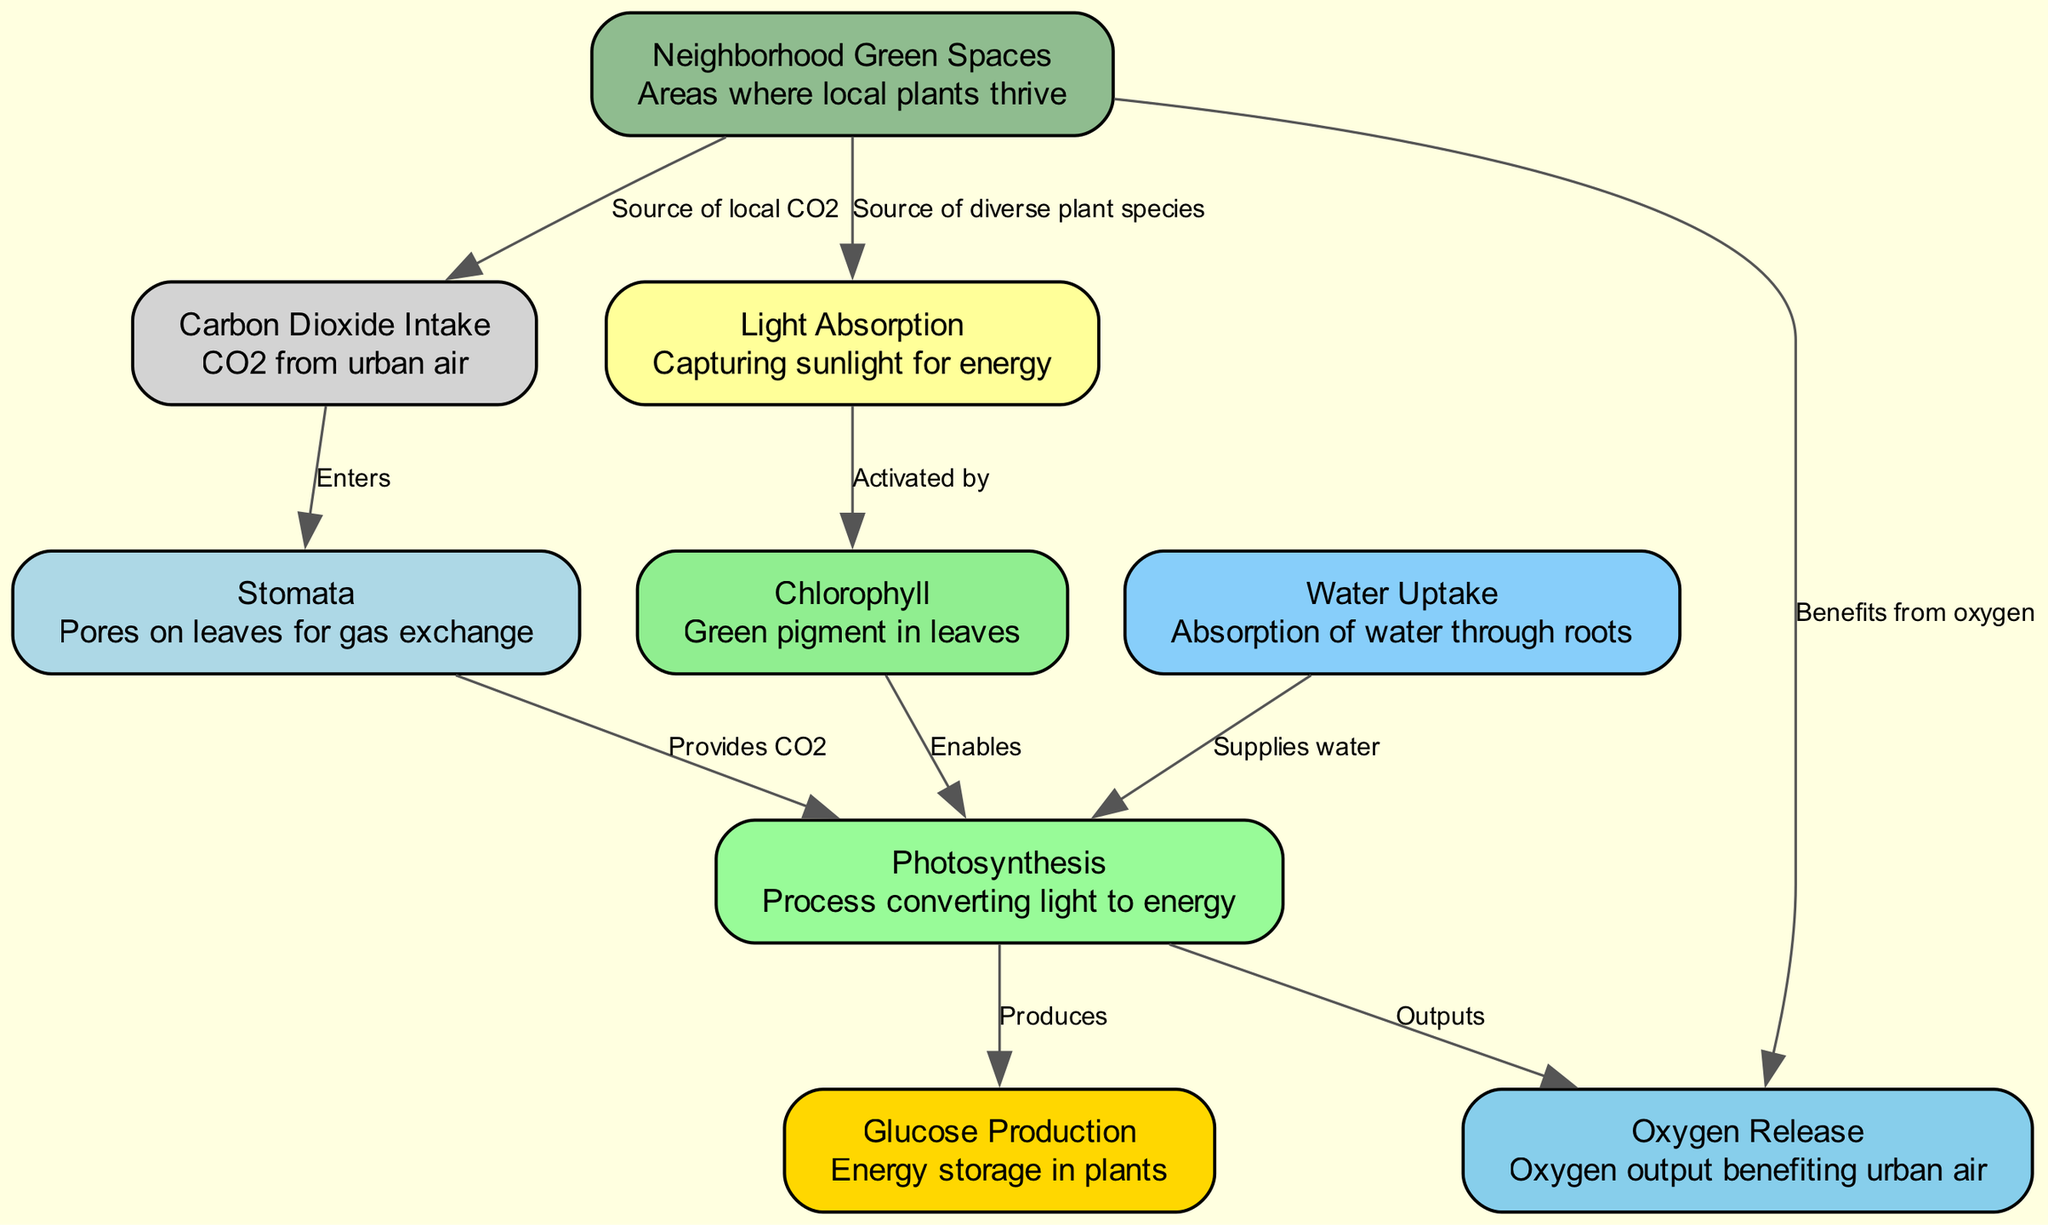What is the label of the node that corresponds to sunlight absorption? The node for sunlight absorption is labeled "Light Absorption". This can be determined by looking for the node in the diagram that explicitly mentions the process of capturing sunlight.
Answer: Light Absorption How many edges are shown in the diagram? To count the edges, we can note each connection between nodes. The edges listed show the relationships and there are a total of 9 edges in the diagram.
Answer: 9 Which node represents the process that converts light to energy? The process that converts light to energy is represented by the node labeled "Photosynthesis". This can be found by locating the node that ties together the input of light and outputs the energy forms.
Answer: Photosynthesis What does the "Chlorophyll" node enable in the process? The "Chlorophyll" node enables the "Photosynthesis" process. This connection indicates that chlorophyll is crucial for converting light energy during photosynthesis.
Answer: Photosynthesis Which node receives Carbon Dioxide from urban air? The node that receives Carbon Dioxide from urban air is labeled "Stomata". This can be identified by observing the node that connects to CO2 intake and serves the gas exchange function.
Answer: Stomata Which area benefits from the oxygen released during photosynthesis? The area that benefits from the oxygen released is labeled "Neighborhood Green Spaces". This can be concluded by looking for the node that is indicated to receive the oxygen output from the photosynthesis chain.
Answer: Neighborhood Green Spaces What performs the function of absorbing water for the plant? The function of absorbing water for the plant is performed by the node labeled "Water Uptake". This node directly relates to the roots' capability to supply water for photosynthesis.
Answer: Water Uptake How does "Carbon Dioxide Intake" enter the photosynthesis process? The "Carbon Dioxide Intake" enters through "Stomata", which serves as the entry point for CO2. The connection indicates that CO2 gas enters leaves through these pores to facilitate photosynthesis.
Answer: Stomata What is the output of the photosynthesis process? The outputs of the photosynthesis process include "Glucose Production" and "Oxygen Release". This can be concluded from the two nodes indicating the products following the completion of the photosynthesis steps.
Answer: Glucose Production and Oxygen Release 